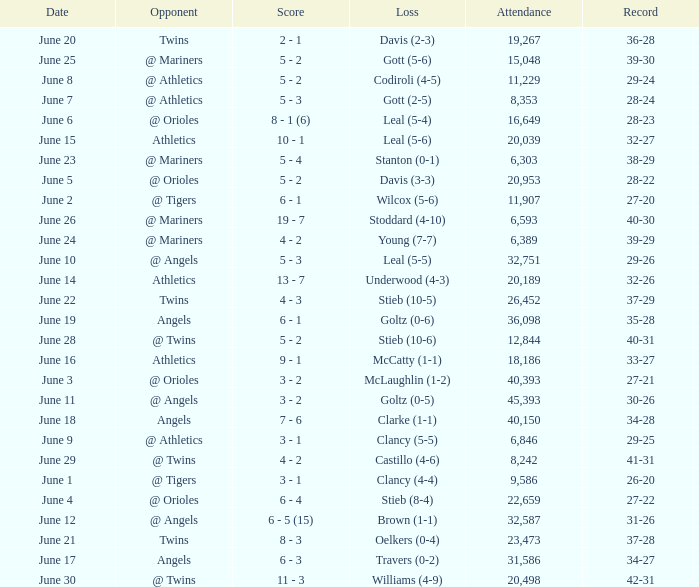What was the record for the date of June 14? 32-26. 